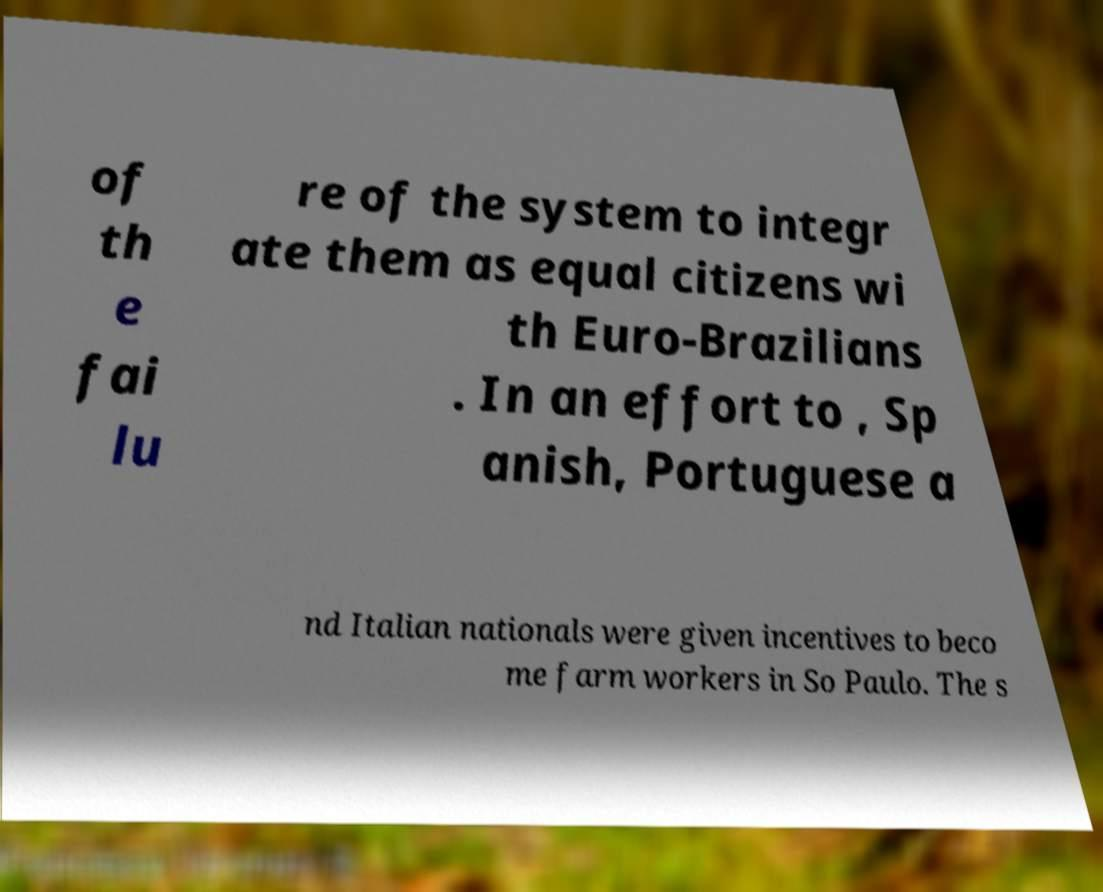There's text embedded in this image that I need extracted. Can you transcribe it verbatim? of th e fai lu re of the system to integr ate them as equal citizens wi th Euro-Brazilians . In an effort to , Sp anish, Portuguese a nd Italian nationals were given incentives to beco me farm workers in So Paulo. The s 